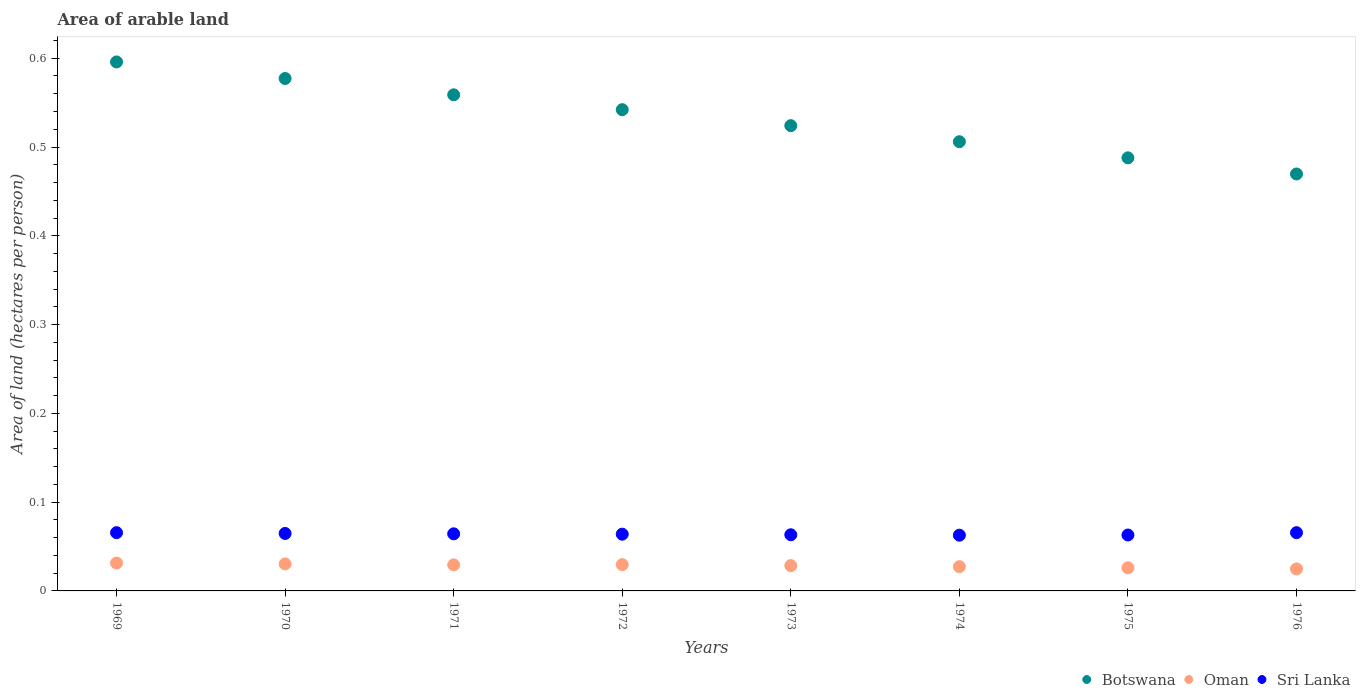How many different coloured dotlines are there?
Your response must be concise. 3. Is the number of dotlines equal to the number of legend labels?
Keep it short and to the point. Yes. What is the total arable land in Sri Lanka in 1973?
Make the answer very short. 0.06. Across all years, what is the maximum total arable land in Oman?
Provide a short and direct response. 0.03. Across all years, what is the minimum total arable land in Sri Lanka?
Keep it short and to the point. 0.06. In which year was the total arable land in Sri Lanka maximum?
Your answer should be very brief. 1969. In which year was the total arable land in Sri Lanka minimum?
Your answer should be compact. 1974. What is the total total arable land in Sri Lanka in the graph?
Keep it short and to the point. 0.51. What is the difference between the total arable land in Oman in 1971 and that in 1976?
Provide a short and direct response. 0. What is the difference between the total arable land in Sri Lanka in 1975 and the total arable land in Oman in 1972?
Give a very brief answer. 0.03. What is the average total arable land in Sri Lanka per year?
Your answer should be compact. 0.06. In the year 1971, what is the difference between the total arable land in Sri Lanka and total arable land in Botswana?
Your answer should be compact. -0.49. In how many years, is the total arable land in Oman greater than 0.04 hectares per person?
Your response must be concise. 0. What is the ratio of the total arable land in Oman in 1970 to that in 1972?
Provide a short and direct response. 1.03. Is the total arable land in Oman in 1974 less than that in 1976?
Your answer should be very brief. No. What is the difference between the highest and the second highest total arable land in Botswana?
Offer a very short reply. 0.02. What is the difference between the highest and the lowest total arable land in Botswana?
Keep it short and to the point. 0.13. Is the sum of the total arable land in Botswana in 1969 and 1976 greater than the maximum total arable land in Oman across all years?
Offer a terse response. Yes. Is the total arable land in Oman strictly less than the total arable land in Botswana over the years?
Your answer should be compact. Yes. How many dotlines are there?
Your answer should be compact. 3. What is the difference between two consecutive major ticks on the Y-axis?
Ensure brevity in your answer.  0.1. Are the values on the major ticks of Y-axis written in scientific E-notation?
Your response must be concise. No. Where does the legend appear in the graph?
Provide a succinct answer. Bottom right. How many legend labels are there?
Your answer should be compact. 3. What is the title of the graph?
Ensure brevity in your answer.  Area of arable land. What is the label or title of the Y-axis?
Your answer should be very brief. Area of land (hectares per person). What is the Area of land (hectares per person) in Botswana in 1969?
Provide a short and direct response. 0.6. What is the Area of land (hectares per person) in Oman in 1969?
Keep it short and to the point. 0.03. What is the Area of land (hectares per person) of Sri Lanka in 1969?
Keep it short and to the point. 0.07. What is the Area of land (hectares per person) of Botswana in 1970?
Make the answer very short. 0.58. What is the Area of land (hectares per person) of Oman in 1970?
Offer a terse response. 0.03. What is the Area of land (hectares per person) in Sri Lanka in 1970?
Provide a short and direct response. 0.06. What is the Area of land (hectares per person) in Botswana in 1971?
Your answer should be compact. 0.56. What is the Area of land (hectares per person) of Oman in 1971?
Ensure brevity in your answer.  0.03. What is the Area of land (hectares per person) in Sri Lanka in 1971?
Provide a short and direct response. 0.06. What is the Area of land (hectares per person) of Botswana in 1972?
Your response must be concise. 0.54. What is the Area of land (hectares per person) of Oman in 1972?
Make the answer very short. 0.03. What is the Area of land (hectares per person) of Sri Lanka in 1972?
Your answer should be compact. 0.06. What is the Area of land (hectares per person) of Botswana in 1973?
Ensure brevity in your answer.  0.52. What is the Area of land (hectares per person) of Oman in 1973?
Provide a succinct answer. 0.03. What is the Area of land (hectares per person) in Sri Lanka in 1973?
Your answer should be compact. 0.06. What is the Area of land (hectares per person) in Botswana in 1974?
Ensure brevity in your answer.  0.51. What is the Area of land (hectares per person) of Oman in 1974?
Your response must be concise. 0.03. What is the Area of land (hectares per person) in Sri Lanka in 1974?
Your answer should be compact. 0.06. What is the Area of land (hectares per person) of Botswana in 1975?
Your answer should be very brief. 0.49. What is the Area of land (hectares per person) of Oman in 1975?
Provide a succinct answer. 0.03. What is the Area of land (hectares per person) of Sri Lanka in 1975?
Your response must be concise. 0.06. What is the Area of land (hectares per person) in Botswana in 1976?
Offer a terse response. 0.47. What is the Area of land (hectares per person) of Oman in 1976?
Provide a short and direct response. 0.02. What is the Area of land (hectares per person) of Sri Lanka in 1976?
Offer a terse response. 0.07. Across all years, what is the maximum Area of land (hectares per person) of Botswana?
Offer a very short reply. 0.6. Across all years, what is the maximum Area of land (hectares per person) of Oman?
Provide a short and direct response. 0.03. Across all years, what is the maximum Area of land (hectares per person) of Sri Lanka?
Give a very brief answer. 0.07. Across all years, what is the minimum Area of land (hectares per person) of Botswana?
Provide a succinct answer. 0.47. Across all years, what is the minimum Area of land (hectares per person) in Oman?
Make the answer very short. 0.02. Across all years, what is the minimum Area of land (hectares per person) of Sri Lanka?
Ensure brevity in your answer.  0.06. What is the total Area of land (hectares per person) of Botswana in the graph?
Your answer should be very brief. 4.26. What is the total Area of land (hectares per person) in Oman in the graph?
Keep it short and to the point. 0.23. What is the total Area of land (hectares per person) of Sri Lanka in the graph?
Ensure brevity in your answer.  0.51. What is the difference between the Area of land (hectares per person) in Botswana in 1969 and that in 1970?
Ensure brevity in your answer.  0.02. What is the difference between the Area of land (hectares per person) of Sri Lanka in 1969 and that in 1970?
Provide a short and direct response. 0. What is the difference between the Area of land (hectares per person) in Botswana in 1969 and that in 1971?
Ensure brevity in your answer.  0.04. What is the difference between the Area of land (hectares per person) of Oman in 1969 and that in 1971?
Your response must be concise. 0. What is the difference between the Area of land (hectares per person) in Sri Lanka in 1969 and that in 1971?
Keep it short and to the point. 0. What is the difference between the Area of land (hectares per person) in Botswana in 1969 and that in 1972?
Your response must be concise. 0.05. What is the difference between the Area of land (hectares per person) in Oman in 1969 and that in 1972?
Your answer should be very brief. 0. What is the difference between the Area of land (hectares per person) in Sri Lanka in 1969 and that in 1972?
Your answer should be very brief. 0. What is the difference between the Area of land (hectares per person) in Botswana in 1969 and that in 1973?
Keep it short and to the point. 0.07. What is the difference between the Area of land (hectares per person) in Oman in 1969 and that in 1973?
Keep it short and to the point. 0. What is the difference between the Area of land (hectares per person) of Sri Lanka in 1969 and that in 1973?
Offer a very short reply. 0. What is the difference between the Area of land (hectares per person) of Botswana in 1969 and that in 1974?
Your answer should be compact. 0.09. What is the difference between the Area of land (hectares per person) in Oman in 1969 and that in 1974?
Offer a terse response. 0. What is the difference between the Area of land (hectares per person) of Sri Lanka in 1969 and that in 1974?
Provide a short and direct response. 0. What is the difference between the Area of land (hectares per person) of Botswana in 1969 and that in 1975?
Offer a very short reply. 0.11. What is the difference between the Area of land (hectares per person) in Oman in 1969 and that in 1975?
Ensure brevity in your answer.  0.01. What is the difference between the Area of land (hectares per person) of Sri Lanka in 1969 and that in 1975?
Your response must be concise. 0. What is the difference between the Area of land (hectares per person) of Botswana in 1969 and that in 1976?
Give a very brief answer. 0.13. What is the difference between the Area of land (hectares per person) in Oman in 1969 and that in 1976?
Your answer should be compact. 0.01. What is the difference between the Area of land (hectares per person) in Sri Lanka in 1969 and that in 1976?
Keep it short and to the point. 0. What is the difference between the Area of land (hectares per person) of Botswana in 1970 and that in 1971?
Offer a terse response. 0.02. What is the difference between the Area of land (hectares per person) in Botswana in 1970 and that in 1972?
Offer a terse response. 0.04. What is the difference between the Area of land (hectares per person) in Oman in 1970 and that in 1972?
Make the answer very short. 0. What is the difference between the Area of land (hectares per person) of Sri Lanka in 1970 and that in 1972?
Keep it short and to the point. 0. What is the difference between the Area of land (hectares per person) of Botswana in 1970 and that in 1973?
Offer a terse response. 0.05. What is the difference between the Area of land (hectares per person) in Oman in 1970 and that in 1973?
Provide a succinct answer. 0. What is the difference between the Area of land (hectares per person) in Sri Lanka in 1970 and that in 1973?
Your answer should be very brief. 0. What is the difference between the Area of land (hectares per person) of Botswana in 1970 and that in 1974?
Your answer should be very brief. 0.07. What is the difference between the Area of land (hectares per person) of Oman in 1970 and that in 1974?
Make the answer very short. 0. What is the difference between the Area of land (hectares per person) in Sri Lanka in 1970 and that in 1974?
Keep it short and to the point. 0. What is the difference between the Area of land (hectares per person) in Botswana in 1970 and that in 1975?
Your response must be concise. 0.09. What is the difference between the Area of land (hectares per person) of Oman in 1970 and that in 1975?
Your answer should be compact. 0. What is the difference between the Area of land (hectares per person) of Sri Lanka in 1970 and that in 1975?
Provide a succinct answer. 0. What is the difference between the Area of land (hectares per person) in Botswana in 1970 and that in 1976?
Give a very brief answer. 0.11. What is the difference between the Area of land (hectares per person) in Oman in 1970 and that in 1976?
Give a very brief answer. 0.01. What is the difference between the Area of land (hectares per person) of Sri Lanka in 1970 and that in 1976?
Make the answer very short. -0. What is the difference between the Area of land (hectares per person) in Botswana in 1971 and that in 1972?
Provide a short and direct response. 0.02. What is the difference between the Area of land (hectares per person) of Oman in 1971 and that in 1972?
Provide a succinct answer. -0. What is the difference between the Area of land (hectares per person) of Botswana in 1971 and that in 1973?
Keep it short and to the point. 0.03. What is the difference between the Area of land (hectares per person) of Oman in 1971 and that in 1973?
Make the answer very short. 0. What is the difference between the Area of land (hectares per person) of Sri Lanka in 1971 and that in 1973?
Ensure brevity in your answer.  0. What is the difference between the Area of land (hectares per person) in Botswana in 1971 and that in 1974?
Give a very brief answer. 0.05. What is the difference between the Area of land (hectares per person) of Oman in 1971 and that in 1974?
Provide a short and direct response. 0. What is the difference between the Area of land (hectares per person) of Sri Lanka in 1971 and that in 1974?
Your answer should be compact. 0. What is the difference between the Area of land (hectares per person) in Botswana in 1971 and that in 1975?
Offer a very short reply. 0.07. What is the difference between the Area of land (hectares per person) of Oman in 1971 and that in 1975?
Make the answer very short. 0. What is the difference between the Area of land (hectares per person) of Sri Lanka in 1971 and that in 1975?
Offer a terse response. 0. What is the difference between the Area of land (hectares per person) in Botswana in 1971 and that in 1976?
Offer a very short reply. 0.09. What is the difference between the Area of land (hectares per person) of Oman in 1971 and that in 1976?
Your answer should be compact. 0. What is the difference between the Area of land (hectares per person) of Sri Lanka in 1971 and that in 1976?
Offer a very short reply. -0. What is the difference between the Area of land (hectares per person) in Botswana in 1972 and that in 1973?
Your answer should be very brief. 0.02. What is the difference between the Area of land (hectares per person) of Oman in 1972 and that in 1973?
Give a very brief answer. 0. What is the difference between the Area of land (hectares per person) in Sri Lanka in 1972 and that in 1973?
Provide a succinct answer. 0. What is the difference between the Area of land (hectares per person) in Botswana in 1972 and that in 1974?
Provide a short and direct response. 0.04. What is the difference between the Area of land (hectares per person) of Oman in 1972 and that in 1974?
Provide a succinct answer. 0. What is the difference between the Area of land (hectares per person) in Sri Lanka in 1972 and that in 1974?
Provide a succinct answer. 0. What is the difference between the Area of land (hectares per person) in Botswana in 1972 and that in 1975?
Offer a terse response. 0.05. What is the difference between the Area of land (hectares per person) of Oman in 1972 and that in 1975?
Provide a short and direct response. 0. What is the difference between the Area of land (hectares per person) of Sri Lanka in 1972 and that in 1975?
Provide a short and direct response. 0. What is the difference between the Area of land (hectares per person) of Botswana in 1972 and that in 1976?
Ensure brevity in your answer.  0.07. What is the difference between the Area of land (hectares per person) in Oman in 1972 and that in 1976?
Keep it short and to the point. 0. What is the difference between the Area of land (hectares per person) in Sri Lanka in 1972 and that in 1976?
Your response must be concise. -0. What is the difference between the Area of land (hectares per person) of Botswana in 1973 and that in 1974?
Offer a very short reply. 0.02. What is the difference between the Area of land (hectares per person) of Oman in 1973 and that in 1974?
Your answer should be very brief. 0. What is the difference between the Area of land (hectares per person) in Sri Lanka in 1973 and that in 1974?
Offer a terse response. 0. What is the difference between the Area of land (hectares per person) in Botswana in 1973 and that in 1975?
Ensure brevity in your answer.  0.04. What is the difference between the Area of land (hectares per person) in Oman in 1973 and that in 1975?
Your response must be concise. 0. What is the difference between the Area of land (hectares per person) of Botswana in 1973 and that in 1976?
Provide a short and direct response. 0.05. What is the difference between the Area of land (hectares per person) in Oman in 1973 and that in 1976?
Keep it short and to the point. 0. What is the difference between the Area of land (hectares per person) in Sri Lanka in 1973 and that in 1976?
Offer a very short reply. -0. What is the difference between the Area of land (hectares per person) in Botswana in 1974 and that in 1975?
Keep it short and to the point. 0.02. What is the difference between the Area of land (hectares per person) of Oman in 1974 and that in 1975?
Offer a very short reply. 0. What is the difference between the Area of land (hectares per person) of Sri Lanka in 1974 and that in 1975?
Keep it short and to the point. -0. What is the difference between the Area of land (hectares per person) of Botswana in 1974 and that in 1976?
Make the answer very short. 0.04. What is the difference between the Area of land (hectares per person) in Oman in 1974 and that in 1976?
Provide a short and direct response. 0. What is the difference between the Area of land (hectares per person) in Sri Lanka in 1974 and that in 1976?
Offer a very short reply. -0. What is the difference between the Area of land (hectares per person) in Botswana in 1975 and that in 1976?
Make the answer very short. 0.02. What is the difference between the Area of land (hectares per person) in Oman in 1975 and that in 1976?
Make the answer very short. 0. What is the difference between the Area of land (hectares per person) of Sri Lanka in 1975 and that in 1976?
Your answer should be very brief. -0. What is the difference between the Area of land (hectares per person) of Botswana in 1969 and the Area of land (hectares per person) of Oman in 1970?
Your answer should be compact. 0.57. What is the difference between the Area of land (hectares per person) of Botswana in 1969 and the Area of land (hectares per person) of Sri Lanka in 1970?
Provide a short and direct response. 0.53. What is the difference between the Area of land (hectares per person) of Oman in 1969 and the Area of land (hectares per person) of Sri Lanka in 1970?
Provide a succinct answer. -0.03. What is the difference between the Area of land (hectares per person) in Botswana in 1969 and the Area of land (hectares per person) in Oman in 1971?
Make the answer very short. 0.57. What is the difference between the Area of land (hectares per person) in Botswana in 1969 and the Area of land (hectares per person) in Sri Lanka in 1971?
Provide a succinct answer. 0.53. What is the difference between the Area of land (hectares per person) of Oman in 1969 and the Area of land (hectares per person) of Sri Lanka in 1971?
Ensure brevity in your answer.  -0.03. What is the difference between the Area of land (hectares per person) of Botswana in 1969 and the Area of land (hectares per person) of Oman in 1972?
Provide a succinct answer. 0.57. What is the difference between the Area of land (hectares per person) of Botswana in 1969 and the Area of land (hectares per person) of Sri Lanka in 1972?
Give a very brief answer. 0.53. What is the difference between the Area of land (hectares per person) in Oman in 1969 and the Area of land (hectares per person) in Sri Lanka in 1972?
Ensure brevity in your answer.  -0.03. What is the difference between the Area of land (hectares per person) of Botswana in 1969 and the Area of land (hectares per person) of Oman in 1973?
Offer a terse response. 0.57. What is the difference between the Area of land (hectares per person) of Botswana in 1969 and the Area of land (hectares per person) of Sri Lanka in 1973?
Offer a terse response. 0.53. What is the difference between the Area of land (hectares per person) in Oman in 1969 and the Area of land (hectares per person) in Sri Lanka in 1973?
Provide a short and direct response. -0.03. What is the difference between the Area of land (hectares per person) in Botswana in 1969 and the Area of land (hectares per person) in Oman in 1974?
Provide a succinct answer. 0.57. What is the difference between the Area of land (hectares per person) in Botswana in 1969 and the Area of land (hectares per person) in Sri Lanka in 1974?
Your response must be concise. 0.53. What is the difference between the Area of land (hectares per person) in Oman in 1969 and the Area of land (hectares per person) in Sri Lanka in 1974?
Your answer should be compact. -0.03. What is the difference between the Area of land (hectares per person) of Botswana in 1969 and the Area of land (hectares per person) of Oman in 1975?
Your answer should be compact. 0.57. What is the difference between the Area of land (hectares per person) in Botswana in 1969 and the Area of land (hectares per person) in Sri Lanka in 1975?
Keep it short and to the point. 0.53. What is the difference between the Area of land (hectares per person) in Oman in 1969 and the Area of land (hectares per person) in Sri Lanka in 1975?
Give a very brief answer. -0.03. What is the difference between the Area of land (hectares per person) of Botswana in 1969 and the Area of land (hectares per person) of Oman in 1976?
Offer a terse response. 0.57. What is the difference between the Area of land (hectares per person) of Botswana in 1969 and the Area of land (hectares per person) of Sri Lanka in 1976?
Your answer should be compact. 0.53. What is the difference between the Area of land (hectares per person) in Oman in 1969 and the Area of land (hectares per person) in Sri Lanka in 1976?
Make the answer very short. -0.03. What is the difference between the Area of land (hectares per person) of Botswana in 1970 and the Area of land (hectares per person) of Oman in 1971?
Offer a terse response. 0.55. What is the difference between the Area of land (hectares per person) of Botswana in 1970 and the Area of land (hectares per person) of Sri Lanka in 1971?
Give a very brief answer. 0.51. What is the difference between the Area of land (hectares per person) in Oman in 1970 and the Area of land (hectares per person) in Sri Lanka in 1971?
Provide a short and direct response. -0.03. What is the difference between the Area of land (hectares per person) in Botswana in 1970 and the Area of land (hectares per person) in Oman in 1972?
Your answer should be compact. 0.55. What is the difference between the Area of land (hectares per person) of Botswana in 1970 and the Area of land (hectares per person) of Sri Lanka in 1972?
Offer a terse response. 0.51. What is the difference between the Area of land (hectares per person) of Oman in 1970 and the Area of land (hectares per person) of Sri Lanka in 1972?
Offer a very short reply. -0.03. What is the difference between the Area of land (hectares per person) of Botswana in 1970 and the Area of land (hectares per person) of Oman in 1973?
Your answer should be very brief. 0.55. What is the difference between the Area of land (hectares per person) of Botswana in 1970 and the Area of land (hectares per person) of Sri Lanka in 1973?
Make the answer very short. 0.51. What is the difference between the Area of land (hectares per person) in Oman in 1970 and the Area of land (hectares per person) in Sri Lanka in 1973?
Offer a terse response. -0.03. What is the difference between the Area of land (hectares per person) in Botswana in 1970 and the Area of land (hectares per person) in Oman in 1974?
Offer a very short reply. 0.55. What is the difference between the Area of land (hectares per person) in Botswana in 1970 and the Area of land (hectares per person) in Sri Lanka in 1974?
Your answer should be very brief. 0.51. What is the difference between the Area of land (hectares per person) in Oman in 1970 and the Area of land (hectares per person) in Sri Lanka in 1974?
Provide a short and direct response. -0.03. What is the difference between the Area of land (hectares per person) in Botswana in 1970 and the Area of land (hectares per person) in Oman in 1975?
Give a very brief answer. 0.55. What is the difference between the Area of land (hectares per person) of Botswana in 1970 and the Area of land (hectares per person) of Sri Lanka in 1975?
Your answer should be very brief. 0.51. What is the difference between the Area of land (hectares per person) of Oman in 1970 and the Area of land (hectares per person) of Sri Lanka in 1975?
Offer a very short reply. -0.03. What is the difference between the Area of land (hectares per person) in Botswana in 1970 and the Area of land (hectares per person) in Oman in 1976?
Give a very brief answer. 0.55. What is the difference between the Area of land (hectares per person) of Botswana in 1970 and the Area of land (hectares per person) of Sri Lanka in 1976?
Keep it short and to the point. 0.51. What is the difference between the Area of land (hectares per person) of Oman in 1970 and the Area of land (hectares per person) of Sri Lanka in 1976?
Your answer should be compact. -0.04. What is the difference between the Area of land (hectares per person) of Botswana in 1971 and the Area of land (hectares per person) of Oman in 1972?
Your answer should be very brief. 0.53. What is the difference between the Area of land (hectares per person) in Botswana in 1971 and the Area of land (hectares per person) in Sri Lanka in 1972?
Give a very brief answer. 0.49. What is the difference between the Area of land (hectares per person) in Oman in 1971 and the Area of land (hectares per person) in Sri Lanka in 1972?
Ensure brevity in your answer.  -0.03. What is the difference between the Area of land (hectares per person) in Botswana in 1971 and the Area of land (hectares per person) in Oman in 1973?
Offer a terse response. 0.53. What is the difference between the Area of land (hectares per person) of Botswana in 1971 and the Area of land (hectares per person) of Sri Lanka in 1973?
Provide a short and direct response. 0.5. What is the difference between the Area of land (hectares per person) in Oman in 1971 and the Area of land (hectares per person) in Sri Lanka in 1973?
Make the answer very short. -0.03. What is the difference between the Area of land (hectares per person) of Botswana in 1971 and the Area of land (hectares per person) of Oman in 1974?
Make the answer very short. 0.53. What is the difference between the Area of land (hectares per person) in Botswana in 1971 and the Area of land (hectares per person) in Sri Lanka in 1974?
Offer a very short reply. 0.5. What is the difference between the Area of land (hectares per person) of Oman in 1971 and the Area of land (hectares per person) of Sri Lanka in 1974?
Ensure brevity in your answer.  -0.03. What is the difference between the Area of land (hectares per person) of Botswana in 1971 and the Area of land (hectares per person) of Oman in 1975?
Ensure brevity in your answer.  0.53. What is the difference between the Area of land (hectares per person) of Botswana in 1971 and the Area of land (hectares per person) of Sri Lanka in 1975?
Your answer should be compact. 0.5. What is the difference between the Area of land (hectares per person) of Oman in 1971 and the Area of land (hectares per person) of Sri Lanka in 1975?
Provide a succinct answer. -0.03. What is the difference between the Area of land (hectares per person) of Botswana in 1971 and the Area of land (hectares per person) of Oman in 1976?
Offer a very short reply. 0.53. What is the difference between the Area of land (hectares per person) in Botswana in 1971 and the Area of land (hectares per person) in Sri Lanka in 1976?
Make the answer very short. 0.49. What is the difference between the Area of land (hectares per person) of Oman in 1971 and the Area of land (hectares per person) of Sri Lanka in 1976?
Your answer should be compact. -0.04. What is the difference between the Area of land (hectares per person) of Botswana in 1972 and the Area of land (hectares per person) of Oman in 1973?
Provide a succinct answer. 0.51. What is the difference between the Area of land (hectares per person) in Botswana in 1972 and the Area of land (hectares per person) in Sri Lanka in 1973?
Your answer should be very brief. 0.48. What is the difference between the Area of land (hectares per person) in Oman in 1972 and the Area of land (hectares per person) in Sri Lanka in 1973?
Ensure brevity in your answer.  -0.03. What is the difference between the Area of land (hectares per person) in Botswana in 1972 and the Area of land (hectares per person) in Oman in 1974?
Your answer should be very brief. 0.51. What is the difference between the Area of land (hectares per person) of Botswana in 1972 and the Area of land (hectares per person) of Sri Lanka in 1974?
Provide a succinct answer. 0.48. What is the difference between the Area of land (hectares per person) of Oman in 1972 and the Area of land (hectares per person) of Sri Lanka in 1974?
Ensure brevity in your answer.  -0.03. What is the difference between the Area of land (hectares per person) of Botswana in 1972 and the Area of land (hectares per person) of Oman in 1975?
Your answer should be compact. 0.52. What is the difference between the Area of land (hectares per person) in Botswana in 1972 and the Area of land (hectares per person) in Sri Lanka in 1975?
Ensure brevity in your answer.  0.48. What is the difference between the Area of land (hectares per person) in Oman in 1972 and the Area of land (hectares per person) in Sri Lanka in 1975?
Make the answer very short. -0.03. What is the difference between the Area of land (hectares per person) in Botswana in 1972 and the Area of land (hectares per person) in Oman in 1976?
Provide a short and direct response. 0.52. What is the difference between the Area of land (hectares per person) in Botswana in 1972 and the Area of land (hectares per person) in Sri Lanka in 1976?
Make the answer very short. 0.48. What is the difference between the Area of land (hectares per person) in Oman in 1972 and the Area of land (hectares per person) in Sri Lanka in 1976?
Ensure brevity in your answer.  -0.04. What is the difference between the Area of land (hectares per person) of Botswana in 1973 and the Area of land (hectares per person) of Oman in 1974?
Give a very brief answer. 0.5. What is the difference between the Area of land (hectares per person) of Botswana in 1973 and the Area of land (hectares per person) of Sri Lanka in 1974?
Ensure brevity in your answer.  0.46. What is the difference between the Area of land (hectares per person) in Oman in 1973 and the Area of land (hectares per person) in Sri Lanka in 1974?
Offer a terse response. -0.03. What is the difference between the Area of land (hectares per person) of Botswana in 1973 and the Area of land (hectares per person) of Oman in 1975?
Provide a succinct answer. 0.5. What is the difference between the Area of land (hectares per person) of Botswana in 1973 and the Area of land (hectares per person) of Sri Lanka in 1975?
Offer a terse response. 0.46. What is the difference between the Area of land (hectares per person) in Oman in 1973 and the Area of land (hectares per person) in Sri Lanka in 1975?
Your answer should be compact. -0.03. What is the difference between the Area of land (hectares per person) in Botswana in 1973 and the Area of land (hectares per person) in Oman in 1976?
Give a very brief answer. 0.5. What is the difference between the Area of land (hectares per person) of Botswana in 1973 and the Area of land (hectares per person) of Sri Lanka in 1976?
Your response must be concise. 0.46. What is the difference between the Area of land (hectares per person) of Oman in 1973 and the Area of land (hectares per person) of Sri Lanka in 1976?
Give a very brief answer. -0.04. What is the difference between the Area of land (hectares per person) in Botswana in 1974 and the Area of land (hectares per person) in Oman in 1975?
Offer a terse response. 0.48. What is the difference between the Area of land (hectares per person) in Botswana in 1974 and the Area of land (hectares per person) in Sri Lanka in 1975?
Your answer should be very brief. 0.44. What is the difference between the Area of land (hectares per person) of Oman in 1974 and the Area of land (hectares per person) of Sri Lanka in 1975?
Provide a short and direct response. -0.04. What is the difference between the Area of land (hectares per person) in Botswana in 1974 and the Area of land (hectares per person) in Oman in 1976?
Offer a terse response. 0.48. What is the difference between the Area of land (hectares per person) in Botswana in 1974 and the Area of land (hectares per person) in Sri Lanka in 1976?
Provide a short and direct response. 0.44. What is the difference between the Area of land (hectares per person) in Oman in 1974 and the Area of land (hectares per person) in Sri Lanka in 1976?
Make the answer very short. -0.04. What is the difference between the Area of land (hectares per person) of Botswana in 1975 and the Area of land (hectares per person) of Oman in 1976?
Offer a terse response. 0.46. What is the difference between the Area of land (hectares per person) in Botswana in 1975 and the Area of land (hectares per person) in Sri Lanka in 1976?
Your response must be concise. 0.42. What is the difference between the Area of land (hectares per person) in Oman in 1975 and the Area of land (hectares per person) in Sri Lanka in 1976?
Your answer should be very brief. -0.04. What is the average Area of land (hectares per person) of Botswana per year?
Provide a succinct answer. 0.53. What is the average Area of land (hectares per person) of Oman per year?
Your response must be concise. 0.03. What is the average Area of land (hectares per person) of Sri Lanka per year?
Your answer should be compact. 0.06. In the year 1969, what is the difference between the Area of land (hectares per person) of Botswana and Area of land (hectares per person) of Oman?
Give a very brief answer. 0.56. In the year 1969, what is the difference between the Area of land (hectares per person) in Botswana and Area of land (hectares per person) in Sri Lanka?
Your response must be concise. 0.53. In the year 1969, what is the difference between the Area of land (hectares per person) in Oman and Area of land (hectares per person) in Sri Lanka?
Provide a short and direct response. -0.03. In the year 1970, what is the difference between the Area of land (hectares per person) of Botswana and Area of land (hectares per person) of Oman?
Your response must be concise. 0.55. In the year 1970, what is the difference between the Area of land (hectares per person) in Botswana and Area of land (hectares per person) in Sri Lanka?
Provide a short and direct response. 0.51. In the year 1970, what is the difference between the Area of land (hectares per person) in Oman and Area of land (hectares per person) in Sri Lanka?
Provide a short and direct response. -0.03. In the year 1971, what is the difference between the Area of land (hectares per person) of Botswana and Area of land (hectares per person) of Oman?
Your response must be concise. 0.53. In the year 1971, what is the difference between the Area of land (hectares per person) in Botswana and Area of land (hectares per person) in Sri Lanka?
Your answer should be compact. 0.49. In the year 1971, what is the difference between the Area of land (hectares per person) of Oman and Area of land (hectares per person) of Sri Lanka?
Ensure brevity in your answer.  -0.03. In the year 1972, what is the difference between the Area of land (hectares per person) of Botswana and Area of land (hectares per person) of Oman?
Your response must be concise. 0.51. In the year 1972, what is the difference between the Area of land (hectares per person) of Botswana and Area of land (hectares per person) of Sri Lanka?
Give a very brief answer. 0.48. In the year 1972, what is the difference between the Area of land (hectares per person) in Oman and Area of land (hectares per person) in Sri Lanka?
Keep it short and to the point. -0.03. In the year 1973, what is the difference between the Area of land (hectares per person) of Botswana and Area of land (hectares per person) of Oman?
Provide a succinct answer. 0.5. In the year 1973, what is the difference between the Area of land (hectares per person) of Botswana and Area of land (hectares per person) of Sri Lanka?
Offer a very short reply. 0.46. In the year 1973, what is the difference between the Area of land (hectares per person) in Oman and Area of land (hectares per person) in Sri Lanka?
Offer a terse response. -0.03. In the year 1974, what is the difference between the Area of land (hectares per person) in Botswana and Area of land (hectares per person) in Oman?
Your answer should be very brief. 0.48. In the year 1974, what is the difference between the Area of land (hectares per person) in Botswana and Area of land (hectares per person) in Sri Lanka?
Your answer should be compact. 0.44. In the year 1974, what is the difference between the Area of land (hectares per person) in Oman and Area of land (hectares per person) in Sri Lanka?
Your answer should be very brief. -0.04. In the year 1975, what is the difference between the Area of land (hectares per person) in Botswana and Area of land (hectares per person) in Oman?
Make the answer very short. 0.46. In the year 1975, what is the difference between the Area of land (hectares per person) in Botswana and Area of land (hectares per person) in Sri Lanka?
Your answer should be very brief. 0.42. In the year 1975, what is the difference between the Area of land (hectares per person) of Oman and Area of land (hectares per person) of Sri Lanka?
Keep it short and to the point. -0.04. In the year 1976, what is the difference between the Area of land (hectares per person) of Botswana and Area of land (hectares per person) of Oman?
Make the answer very short. 0.44. In the year 1976, what is the difference between the Area of land (hectares per person) of Botswana and Area of land (hectares per person) of Sri Lanka?
Keep it short and to the point. 0.4. In the year 1976, what is the difference between the Area of land (hectares per person) of Oman and Area of land (hectares per person) of Sri Lanka?
Keep it short and to the point. -0.04. What is the ratio of the Area of land (hectares per person) in Botswana in 1969 to that in 1970?
Make the answer very short. 1.03. What is the ratio of the Area of land (hectares per person) in Oman in 1969 to that in 1970?
Offer a very short reply. 1.03. What is the ratio of the Area of land (hectares per person) in Sri Lanka in 1969 to that in 1970?
Offer a terse response. 1.01. What is the ratio of the Area of land (hectares per person) in Botswana in 1969 to that in 1971?
Your answer should be compact. 1.07. What is the ratio of the Area of land (hectares per person) in Oman in 1969 to that in 1971?
Your answer should be compact. 1.07. What is the ratio of the Area of land (hectares per person) of Sri Lanka in 1969 to that in 1971?
Your response must be concise. 1.02. What is the ratio of the Area of land (hectares per person) of Botswana in 1969 to that in 1972?
Your answer should be very brief. 1.1. What is the ratio of the Area of land (hectares per person) of Oman in 1969 to that in 1972?
Provide a succinct answer. 1.06. What is the ratio of the Area of land (hectares per person) of Sri Lanka in 1969 to that in 1972?
Make the answer very short. 1.03. What is the ratio of the Area of land (hectares per person) of Botswana in 1969 to that in 1973?
Keep it short and to the point. 1.14. What is the ratio of the Area of land (hectares per person) of Oman in 1969 to that in 1973?
Make the answer very short. 1.1. What is the ratio of the Area of land (hectares per person) of Sri Lanka in 1969 to that in 1973?
Give a very brief answer. 1.04. What is the ratio of the Area of land (hectares per person) in Botswana in 1969 to that in 1974?
Offer a terse response. 1.18. What is the ratio of the Area of land (hectares per person) of Oman in 1969 to that in 1974?
Make the answer very short. 1.15. What is the ratio of the Area of land (hectares per person) in Sri Lanka in 1969 to that in 1974?
Offer a very short reply. 1.05. What is the ratio of the Area of land (hectares per person) of Botswana in 1969 to that in 1975?
Provide a short and direct response. 1.22. What is the ratio of the Area of land (hectares per person) in Oman in 1969 to that in 1975?
Provide a short and direct response. 1.2. What is the ratio of the Area of land (hectares per person) of Sri Lanka in 1969 to that in 1975?
Provide a short and direct response. 1.04. What is the ratio of the Area of land (hectares per person) in Botswana in 1969 to that in 1976?
Provide a short and direct response. 1.27. What is the ratio of the Area of land (hectares per person) in Oman in 1969 to that in 1976?
Ensure brevity in your answer.  1.27. What is the ratio of the Area of land (hectares per person) of Sri Lanka in 1969 to that in 1976?
Give a very brief answer. 1. What is the ratio of the Area of land (hectares per person) in Botswana in 1970 to that in 1971?
Keep it short and to the point. 1.03. What is the ratio of the Area of land (hectares per person) of Oman in 1970 to that in 1971?
Your answer should be very brief. 1.03. What is the ratio of the Area of land (hectares per person) of Sri Lanka in 1970 to that in 1971?
Ensure brevity in your answer.  1.01. What is the ratio of the Area of land (hectares per person) in Botswana in 1970 to that in 1972?
Your answer should be compact. 1.06. What is the ratio of the Area of land (hectares per person) in Oman in 1970 to that in 1972?
Your answer should be compact. 1.03. What is the ratio of the Area of land (hectares per person) of Sri Lanka in 1970 to that in 1972?
Your response must be concise. 1.01. What is the ratio of the Area of land (hectares per person) of Botswana in 1970 to that in 1973?
Offer a very short reply. 1.1. What is the ratio of the Area of land (hectares per person) of Oman in 1970 to that in 1973?
Ensure brevity in your answer.  1.07. What is the ratio of the Area of land (hectares per person) in Sri Lanka in 1970 to that in 1973?
Offer a terse response. 1.02. What is the ratio of the Area of land (hectares per person) of Botswana in 1970 to that in 1974?
Provide a short and direct response. 1.14. What is the ratio of the Area of land (hectares per person) in Oman in 1970 to that in 1974?
Ensure brevity in your answer.  1.11. What is the ratio of the Area of land (hectares per person) of Sri Lanka in 1970 to that in 1974?
Your answer should be compact. 1.03. What is the ratio of the Area of land (hectares per person) of Botswana in 1970 to that in 1975?
Your answer should be very brief. 1.18. What is the ratio of the Area of land (hectares per person) of Oman in 1970 to that in 1975?
Offer a very short reply. 1.17. What is the ratio of the Area of land (hectares per person) of Sri Lanka in 1970 to that in 1975?
Offer a terse response. 1.03. What is the ratio of the Area of land (hectares per person) of Botswana in 1970 to that in 1976?
Keep it short and to the point. 1.23. What is the ratio of the Area of land (hectares per person) in Oman in 1970 to that in 1976?
Provide a short and direct response. 1.23. What is the ratio of the Area of land (hectares per person) of Sri Lanka in 1970 to that in 1976?
Ensure brevity in your answer.  0.99. What is the ratio of the Area of land (hectares per person) of Botswana in 1971 to that in 1972?
Ensure brevity in your answer.  1.03. What is the ratio of the Area of land (hectares per person) in Sri Lanka in 1971 to that in 1972?
Your answer should be very brief. 1.01. What is the ratio of the Area of land (hectares per person) in Botswana in 1971 to that in 1973?
Offer a terse response. 1.07. What is the ratio of the Area of land (hectares per person) in Oman in 1971 to that in 1973?
Your response must be concise. 1.03. What is the ratio of the Area of land (hectares per person) in Sri Lanka in 1971 to that in 1973?
Your answer should be compact. 1.02. What is the ratio of the Area of land (hectares per person) in Botswana in 1971 to that in 1974?
Offer a terse response. 1.1. What is the ratio of the Area of land (hectares per person) of Oman in 1971 to that in 1974?
Give a very brief answer. 1.08. What is the ratio of the Area of land (hectares per person) in Sri Lanka in 1971 to that in 1974?
Ensure brevity in your answer.  1.02. What is the ratio of the Area of land (hectares per person) of Botswana in 1971 to that in 1975?
Your response must be concise. 1.15. What is the ratio of the Area of land (hectares per person) of Oman in 1971 to that in 1975?
Your response must be concise. 1.13. What is the ratio of the Area of land (hectares per person) of Sri Lanka in 1971 to that in 1975?
Offer a very short reply. 1.02. What is the ratio of the Area of land (hectares per person) in Botswana in 1971 to that in 1976?
Provide a short and direct response. 1.19. What is the ratio of the Area of land (hectares per person) of Oman in 1971 to that in 1976?
Ensure brevity in your answer.  1.18. What is the ratio of the Area of land (hectares per person) of Sri Lanka in 1971 to that in 1976?
Provide a succinct answer. 0.98. What is the ratio of the Area of land (hectares per person) in Botswana in 1972 to that in 1973?
Make the answer very short. 1.03. What is the ratio of the Area of land (hectares per person) of Oman in 1972 to that in 1973?
Make the answer very short. 1.04. What is the ratio of the Area of land (hectares per person) in Sri Lanka in 1972 to that in 1973?
Offer a very short reply. 1.01. What is the ratio of the Area of land (hectares per person) in Botswana in 1972 to that in 1974?
Provide a short and direct response. 1.07. What is the ratio of the Area of land (hectares per person) in Oman in 1972 to that in 1974?
Your answer should be compact. 1.08. What is the ratio of the Area of land (hectares per person) of Botswana in 1972 to that in 1975?
Your answer should be very brief. 1.11. What is the ratio of the Area of land (hectares per person) of Oman in 1972 to that in 1975?
Give a very brief answer. 1.14. What is the ratio of the Area of land (hectares per person) in Sri Lanka in 1972 to that in 1975?
Offer a very short reply. 1.01. What is the ratio of the Area of land (hectares per person) in Botswana in 1972 to that in 1976?
Provide a short and direct response. 1.15. What is the ratio of the Area of land (hectares per person) in Oman in 1972 to that in 1976?
Your answer should be compact. 1.19. What is the ratio of the Area of land (hectares per person) in Sri Lanka in 1972 to that in 1976?
Provide a short and direct response. 0.97. What is the ratio of the Area of land (hectares per person) of Botswana in 1973 to that in 1974?
Your answer should be very brief. 1.04. What is the ratio of the Area of land (hectares per person) in Oman in 1973 to that in 1974?
Ensure brevity in your answer.  1.04. What is the ratio of the Area of land (hectares per person) of Sri Lanka in 1973 to that in 1974?
Ensure brevity in your answer.  1.01. What is the ratio of the Area of land (hectares per person) of Botswana in 1973 to that in 1975?
Ensure brevity in your answer.  1.07. What is the ratio of the Area of land (hectares per person) in Oman in 1973 to that in 1975?
Keep it short and to the point. 1.09. What is the ratio of the Area of land (hectares per person) in Botswana in 1973 to that in 1976?
Ensure brevity in your answer.  1.12. What is the ratio of the Area of land (hectares per person) of Oman in 1973 to that in 1976?
Provide a short and direct response. 1.15. What is the ratio of the Area of land (hectares per person) of Sri Lanka in 1973 to that in 1976?
Your response must be concise. 0.96. What is the ratio of the Area of land (hectares per person) of Botswana in 1974 to that in 1975?
Make the answer very short. 1.04. What is the ratio of the Area of land (hectares per person) in Oman in 1974 to that in 1975?
Your answer should be compact. 1.05. What is the ratio of the Area of land (hectares per person) of Botswana in 1974 to that in 1976?
Your answer should be very brief. 1.08. What is the ratio of the Area of land (hectares per person) of Oman in 1974 to that in 1976?
Give a very brief answer. 1.1. What is the ratio of the Area of land (hectares per person) in Sri Lanka in 1974 to that in 1976?
Make the answer very short. 0.96. What is the ratio of the Area of land (hectares per person) of Botswana in 1975 to that in 1976?
Keep it short and to the point. 1.04. What is the ratio of the Area of land (hectares per person) of Oman in 1975 to that in 1976?
Your answer should be very brief. 1.05. What is the ratio of the Area of land (hectares per person) in Sri Lanka in 1975 to that in 1976?
Make the answer very short. 0.96. What is the difference between the highest and the second highest Area of land (hectares per person) of Botswana?
Offer a terse response. 0.02. What is the difference between the highest and the lowest Area of land (hectares per person) in Botswana?
Offer a very short reply. 0.13. What is the difference between the highest and the lowest Area of land (hectares per person) in Oman?
Keep it short and to the point. 0.01. What is the difference between the highest and the lowest Area of land (hectares per person) in Sri Lanka?
Offer a very short reply. 0. 